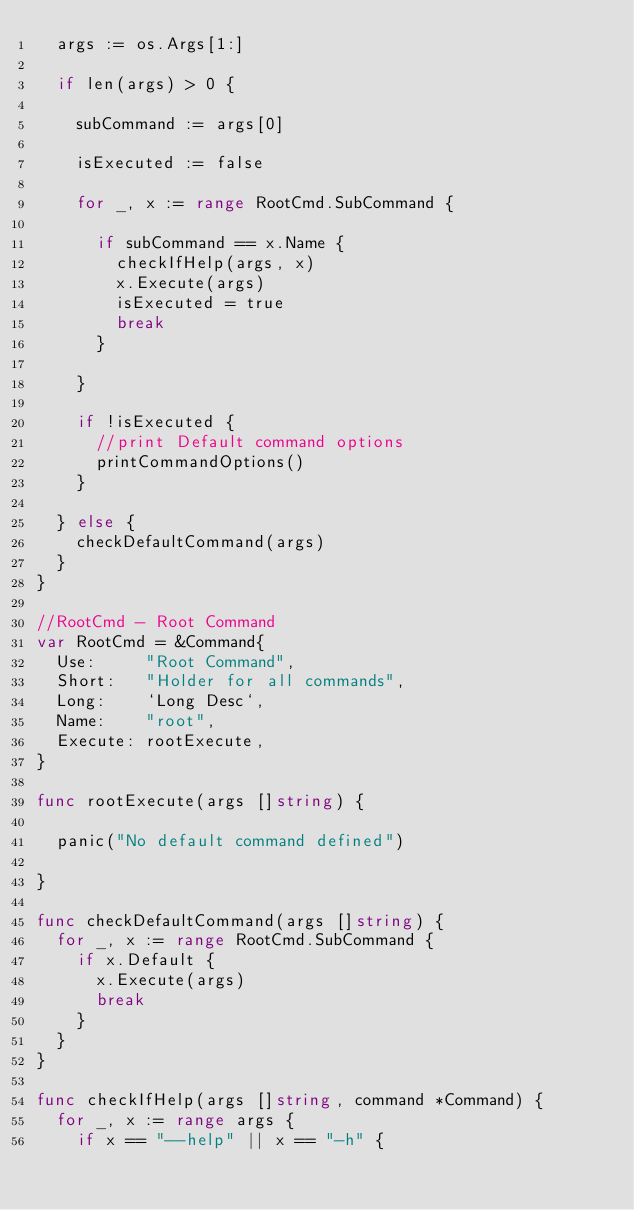<code> <loc_0><loc_0><loc_500><loc_500><_Go_>	args := os.Args[1:]

	if len(args) > 0 {

		subCommand := args[0]

		isExecuted := false

		for _, x := range RootCmd.SubCommand {

			if subCommand == x.Name {
				checkIfHelp(args, x)
				x.Execute(args)
				isExecuted = true
				break
			}

		}

		if !isExecuted {
			//print Default command options
			printCommandOptions()
		}

	} else {
		checkDefaultCommand(args)
	}
}

//RootCmd - Root Command
var RootCmd = &Command{
	Use:     "Root Command",
	Short:   "Holder for all commands",
	Long:    `Long Desc`,
	Name:    "root",
	Execute: rootExecute,
}

func rootExecute(args []string) {

	panic("No default command defined")

}

func checkDefaultCommand(args []string) {
	for _, x := range RootCmd.SubCommand {
		if x.Default {
			x.Execute(args)
			break
		}
	}
}

func checkIfHelp(args []string, command *Command) {
	for _, x := range args {
		if x == "--help" || x == "-h" {
</code> 